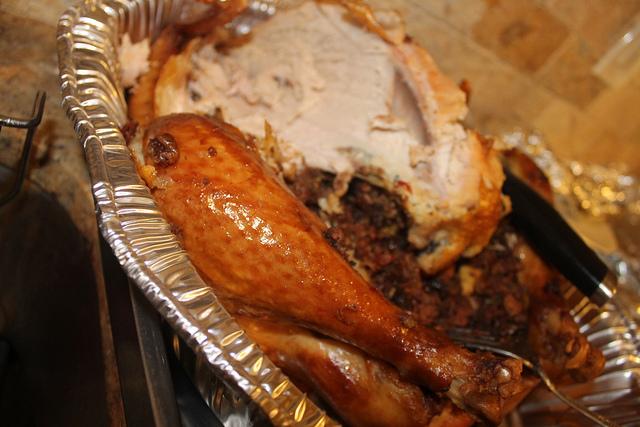Has the turkey been carved?
Write a very short answer. Yes. Is the meat cooked through?
Give a very brief answer. Yes. What material is the turkey container?
Give a very brief answer. Aluminum. 